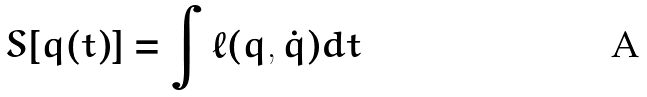<formula> <loc_0><loc_0><loc_500><loc_500>S [ q ( t ) ] = \int \ell ( q , \dot { q } ) d t</formula> 